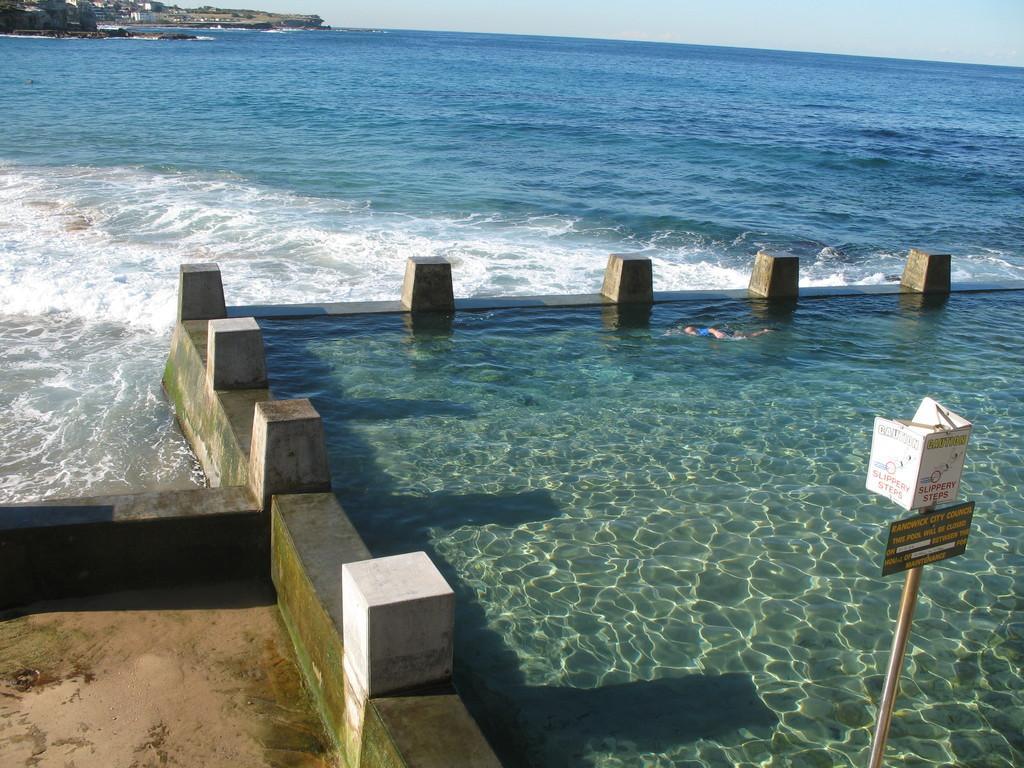Can you describe this image briefly? In this picture in the front there is water and there is a pole, on the pole there are boards with some text written on it and there are stones. In the center there is an ocean. In the background there are buildings and trees. 